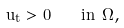Convert formula to latex. <formula><loc_0><loc_0><loc_500><loc_500>u _ { t } > 0 \quad i n \ \Omega ,</formula> 